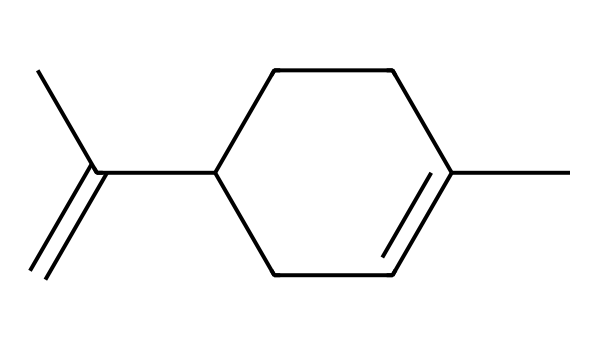What is the name of this compound? The SMILES representation indicates a compound with a specific structure known for its pleasant citrus aroma. This structure corresponds to limonene, a common terpene found in citrus fruits.
Answer: limonene How many carbon atoms are in the structure? By analyzing the SMILES representation, we can count the 'C' symbols which denote carbon atoms. The count shows that there are ten carbon atoms in total.
Answer: ten What type of bond connects the carbon atoms? The structure features both single and double bonds between carbon atoms. Observing the presence of the '=' sign in the SMILES indicates a double bond, while the other connections between carbons are single bonds.
Answer: single and double Is this compound a hydrocarbon or contains functional groups? This compound is a hydrocarbon; it consists solely of hydrogen and carbon atoms. An examination of the formula shows there are no heteroatoms indicating functional groups.
Answer: hydrocarbon What geometric configuration is seen in limonene due to its double bonds? The presence of double bonds in the structure gives rise to a cis or trans configuration, as indicated by the spatial arrangement of the attached groups in the double bond region. This affects the overall shape of the molecule.
Answer: cis and trans configuration What is the largest ring size present in this structure? In the structure represented by the SMILES, there is a cycloalkane component. Counting reveals that the largest ring structure present is six carbons forming a cyclohexane.
Answer: six 